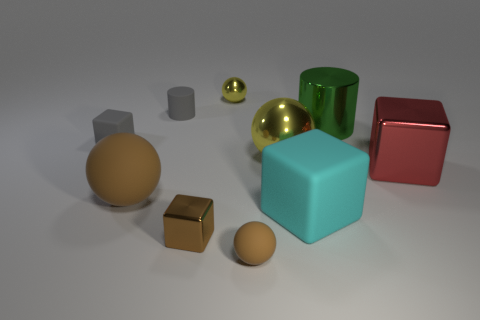Subtract all tiny brown blocks. How many blocks are left? 3 Subtract all brown blocks. How many blocks are left? 3 Subtract all balls. How many objects are left? 6 Subtract 1 brown blocks. How many objects are left? 9 Subtract 2 cylinders. How many cylinders are left? 0 Subtract all gray cylinders. Subtract all red cubes. How many cylinders are left? 1 Subtract all gray cylinders. How many gray cubes are left? 1 Subtract all gray things. Subtract all large green metallic things. How many objects are left? 7 Add 8 tiny brown metallic things. How many tiny brown metallic things are left? 9 Add 1 small gray things. How many small gray things exist? 3 